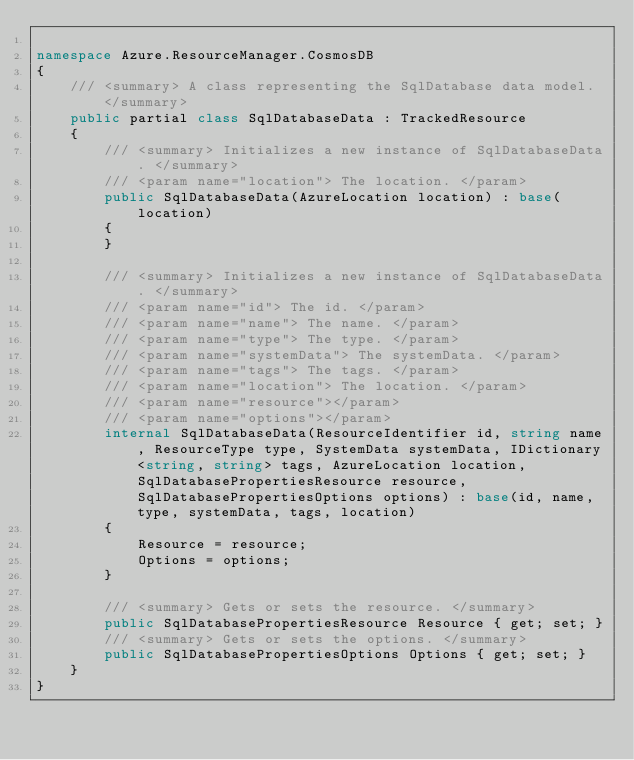<code> <loc_0><loc_0><loc_500><loc_500><_C#_>
namespace Azure.ResourceManager.CosmosDB
{
    /// <summary> A class representing the SqlDatabase data model. </summary>
    public partial class SqlDatabaseData : TrackedResource
    {
        /// <summary> Initializes a new instance of SqlDatabaseData. </summary>
        /// <param name="location"> The location. </param>
        public SqlDatabaseData(AzureLocation location) : base(location)
        {
        }

        /// <summary> Initializes a new instance of SqlDatabaseData. </summary>
        /// <param name="id"> The id. </param>
        /// <param name="name"> The name. </param>
        /// <param name="type"> The type. </param>
        /// <param name="systemData"> The systemData. </param>
        /// <param name="tags"> The tags. </param>
        /// <param name="location"> The location. </param>
        /// <param name="resource"></param>
        /// <param name="options"></param>
        internal SqlDatabaseData(ResourceIdentifier id, string name, ResourceType type, SystemData systemData, IDictionary<string, string> tags, AzureLocation location, SqlDatabasePropertiesResource resource, SqlDatabasePropertiesOptions options) : base(id, name, type, systemData, tags, location)
        {
            Resource = resource;
            Options = options;
        }

        /// <summary> Gets or sets the resource. </summary>
        public SqlDatabasePropertiesResource Resource { get; set; }
        /// <summary> Gets or sets the options. </summary>
        public SqlDatabasePropertiesOptions Options { get; set; }
    }
}
</code> 